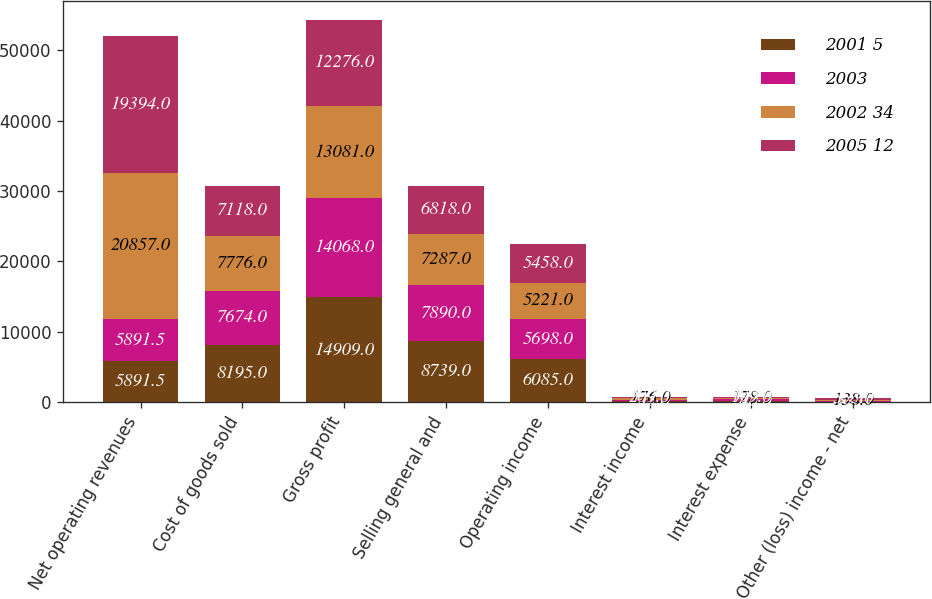Convert chart. <chart><loc_0><loc_0><loc_500><loc_500><stacked_bar_chart><ecel><fcel>Net operating revenues<fcel>Cost of goods sold<fcel>Gross profit<fcel>Selling general and<fcel>Operating income<fcel>Interest income<fcel>Interest expense<fcel>Other (loss) income - net<nl><fcel>2001 5<fcel>5891.5<fcel>8195<fcel>14909<fcel>8739<fcel>6085<fcel>235<fcel>240<fcel>93<nl><fcel>2003<fcel>5891.5<fcel>7674<fcel>14068<fcel>7890<fcel>5698<fcel>157<fcel>196<fcel>82<nl><fcel>2002 34<fcel>20857<fcel>7776<fcel>13081<fcel>7287<fcel>5221<fcel>176<fcel>178<fcel>138<nl><fcel>2005 12<fcel>19394<fcel>7118<fcel>12276<fcel>6818<fcel>5458<fcel>209<fcel>199<fcel>353<nl></chart> 